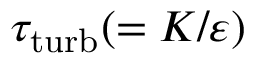<formula> <loc_0><loc_0><loc_500><loc_500>\tau _ { t u r b } ( = K / \varepsilon )</formula> 